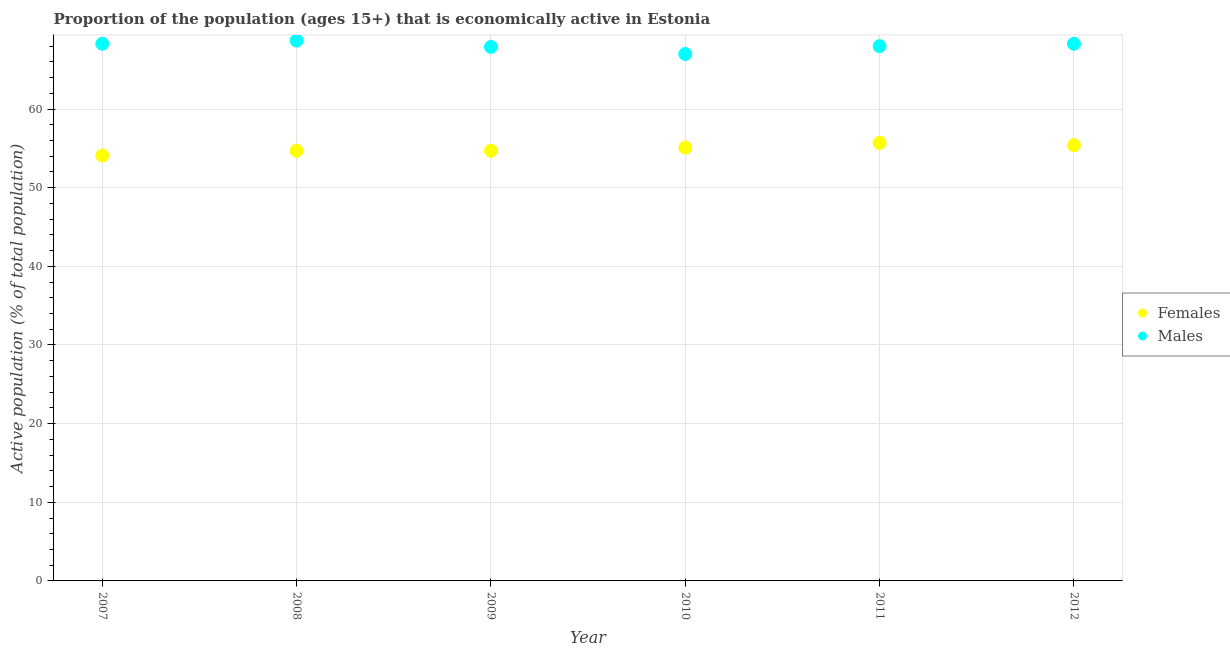Is the number of dotlines equal to the number of legend labels?
Make the answer very short. Yes. What is the percentage of economically active female population in 2008?
Your answer should be very brief. 54.7. Across all years, what is the maximum percentage of economically active female population?
Your answer should be very brief. 55.7. What is the total percentage of economically active female population in the graph?
Provide a succinct answer. 329.7. What is the difference between the percentage of economically active female population in 2007 and that in 2009?
Keep it short and to the point. -0.6. What is the difference between the percentage of economically active male population in 2007 and the percentage of economically active female population in 2008?
Your answer should be compact. 13.6. What is the average percentage of economically active male population per year?
Offer a very short reply. 68.03. In the year 2008, what is the difference between the percentage of economically active female population and percentage of economically active male population?
Your answer should be very brief. -14. What is the ratio of the percentage of economically active male population in 2008 to that in 2010?
Provide a short and direct response. 1.03. Is the percentage of economically active female population in 2007 less than that in 2012?
Offer a terse response. Yes. What is the difference between the highest and the second highest percentage of economically active female population?
Keep it short and to the point. 0.3. What is the difference between the highest and the lowest percentage of economically active female population?
Ensure brevity in your answer.  1.6. Is the sum of the percentage of economically active female population in 2007 and 2011 greater than the maximum percentage of economically active male population across all years?
Provide a succinct answer. Yes. Is the percentage of economically active male population strictly less than the percentage of economically active female population over the years?
Offer a terse response. No. Does the graph contain any zero values?
Your response must be concise. No. Does the graph contain grids?
Give a very brief answer. Yes. Where does the legend appear in the graph?
Your answer should be compact. Center right. How are the legend labels stacked?
Offer a very short reply. Vertical. What is the title of the graph?
Keep it short and to the point. Proportion of the population (ages 15+) that is economically active in Estonia. Does "Domestic Liabilities" appear as one of the legend labels in the graph?
Offer a very short reply. No. What is the label or title of the X-axis?
Offer a terse response. Year. What is the label or title of the Y-axis?
Offer a terse response. Active population (% of total population). What is the Active population (% of total population) in Females in 2007?
Make the answer very short. 54.1. What is the Active population (% of total population) in Males in 2007?
Your answer should be compact. 68.3. What is the Active population (% of total population) in Females in 2008?
Keep it short and to the point. 54.7. What is the Active population (% of total population) of Males in 2008?
Your response must be concise. 68.7. What is the Active population (% of total population) of Females in 2009?
Provide a short and direct response. 54.7. What is the Active population (% of total population) of Males in 2009?
Keep it short and to the point. 67.9. What is the Active population (% of total population) in Females in 2010?
Your answer should be compact. 55.1. What is the Active population (% of total population) of Males in 2010?
Provide a succinct answer. 67. What is the Active population (% of total population) in Females in 2011?
Make the answer very short. 55.7. What is the Active population (% of total population) in Females in 2012?
Your response must be concise. 55.4. What is the Active population (% of total population) of Males in 2012?
Offer a very short reply. 68.3. Across all years, what is the maximum Active population (% of total population) in Females?
Offer a very short reply. 55.7. Across all years, what is the maximum Active population (% of total population) in Males?
Offer a very short reply. 68.7. Across all years, what is the minimum Active population (% of total population) of Females?
Your answer should be compact. 54.1. Across all years, what is the minimum Active population (% of total population) of Males?
Your response must be concise. 67. What is the total Active population (% of total population) in Females in the graph?
Give a very brief answer. 329.7. What is the total Active population (% of total population) in Males in the graph?
Ensure brevity in your answer.  408.2. What is the difference between the Active population (% of total population) of Females in 2007 and that in 2008?
Your response must be concise. -0.6. What is the difference between the Active population (% of total population) in Males in 2007 and that in 2009?
Your response must be concise. 0.4. What is the difference between the Active population (% of total population) in Males in 2007 and that in 2010?
Your answer should be very brief. 1.3. What is the difference between the Active population (% of total population) in Females in 2007 and that in 2011?
Provide a short and direct response. -1.6. What is the difference between the Active population (% of total population) in Females in 2007 and that in 2012?
Offer a terse response. -1.3. What is the difference between the Active population (% of total population) of Females in 2008 and that in 2009?
Offer a very short reply. 0. What is the difference between the Active population (% of total population) of Males in 2008 and that in 2009?
Provide a succinct answer. 0.8. What is the difference between the Active population (% of total population) in Females in 2008 and that in 2010?
Your answer should be very brief. -0.4. What is the difference between the Active population (% of total population) of Males in 2008 and that in 2010?
Ensure brevity in your answer.  1.7. What is the difference between the Active population (% of total population) in Males in 2008 and that in 2011?
Offer a very short reply. 0.7. What is the difference between the Active population (% of total population) of Females in 2008 and that in 2012?
Offer a terse response. -0.7. What is the difference between the Active population (% of total population) of Males in 2009 and that in 2010?
Offer a very short reply. 0.9. What is the difference between the Active population (% of total population) of Males in 2009 and that in 2011?
Give a very brief answer. -0.1. What is the difference between the Active population (% of total population) of Females in 2009 and that in 2012?
Your answer should be compact. -0.7. What is the difference between the Active population (% of total population) in Males in 2009 and that in 2012?
Offer a very short reply. -0.4. What is the difference between the Active population (% of total population) of Females in 2010 and that in 2011?
Make the answer very short. -0.6. What is the difference between the Active population (% of total population) in Males in 2010 and that in 2011?
Offer a very short reply. -1. What is the difference between the Active population (% of total population) of Females in 2010 and that in 2012?
Offer a terse response. -0.3. What is the difference between the Active population (% of total population) in Males in 2011 and that in 2012?
Make the answer very short. -0.3. What is the difference between the Active population (% of total population) in Females in 2007 and the Active population (% of total population) in Males in 2008?
Your answer should be very brief. -14.6. What is the difference between the Active population (% of total population) of Females in 2008 and the Active population (% of total population) of Males in 2011?
Your answer should be compact. -13.3. What is the difference between the Active population (% of total population) of Females in 2009 and the Active population (% of total population) of Males in 2010?
Your answer should be very brief. -12.3. What is the difference between the Active population (% of total population) of Females in 2011 and the Active population (% of total population) of Males in 2012?
Provide a short and direct response. -12.6. What is the average Active population (% of total population) in Females per year?
Offer a very short reply. 54.95. What is the average Active population (% of total population) of Males per year?
Give a very brief answer. 68.03. In the year 2011, what is the difference between the Active population (% of total population) of Females and Active population (% of total population) of Males?
Keep it short and to the point. -12.3. What is the ratio of the Active population (% of total population) of Females in 2007 to that in 2008?
Your answer should be very brief. 0.99. What is the ratio of the Active population (% of total population) of Males in 2007 to that in 2008?
Give a very brief answer. 0.99. What is the ratio of the Active population (% of total population) in Males in 2007 to that in 2009?
Offer a terse response. 1.01. What is the ratio of the Active population (% of total population) in Females in 2007 to that in 2010?
Your answer should be very brief. 0.98. What is the ratio of the Active population (% of total population) in Males in 2007 to that in 2010?
Your answer should be very brief. 1.02. What is the ratio of the Active population (% of total population) of Females in 2007 to that in 2011?
Give a very brief answer. 0.97. What is the ratio of the Active population (% of total population) in Females in 2007 to that in 2012?
Your response must be concise. 0.98. What is the ratio of the Active population (% of total population) of Females in 2008 to that in 2009?
Your response must be concise. 1. What is the ratio of the Active population (% of total population) in Males in 2008 to that in 2009?
Offer a very short reply. 1.01. What is the ratio of the Active population (% of total population) in Males in 2008 to that in 2010?
Your answer should be very brief. 1.03. What is the ratio of the Active population (% of total population) in Females in 2008 to that in 2011?
Your answer should be compact. 0.98. What is the ratio of the Active population (% of total population) of Males in 2008 to that in 2011?
Offer a terse response. 1.01. What is the ratio of the Active population (% of total population) in Females in 2008 to that in 2012?
Offer a terse response. 0.99. What is the ratio of the Active population (% of total population) in Males in 2008 to that in 2012?
Your response must be concise. 1.01. What is the ratio of the Active population (% of total population) of Females in 2009 to that in 2010?
Offer a terse response. 0.99. What is the ratio of the Active population (% of total population) of Males in 2009 to that in 2010?
Your response must be concise. 1.01. What is the ratio of the Active population (% of total population) of Females in 2009 to that in 2011?
Offer a very short reply. 0.98. What is the ratio of the Active population (% of total population) of Males in 2009 to that in 2011?
Your answer should be compact. 1. What is the ratio of the Active population (% of total population) in Females in 2009 to that in 2012?
Ensure brevity in your answer.  0.99. What is the ratio of the Active population (% of total population) of Males in 2009 to that in 2012?
Provide a short and direct response. 0.99. What is the ratio of the Active population (% of total population) of Females in 2010 to that in 2011?
Your response must be concise. 0.99. What is the ratio of the Active population (% of total population) of Females in 2010 to that in 2012?
Offer a terse response. 0.99. What is the ratio of the Active population (% of total population) of Females in 2011 to that in 2012?
Your response must be concise. 1.01. What is the ratio of the Active population (% of total population) in Males in 2011 to that in 2012?
Your response must be concise. 1. What is the difference between the highest and the second highest Active population (% of total population) in Females?
Give a very brief answer. 0.3. What is the difference between the highest and the lowest Active population (% of total population) in Females?
Keep it short and to the point. 1.6. What is the difference between the highest and the lowest Active population (% of total population) in Males?
Offer a very short reply. 1.7. 